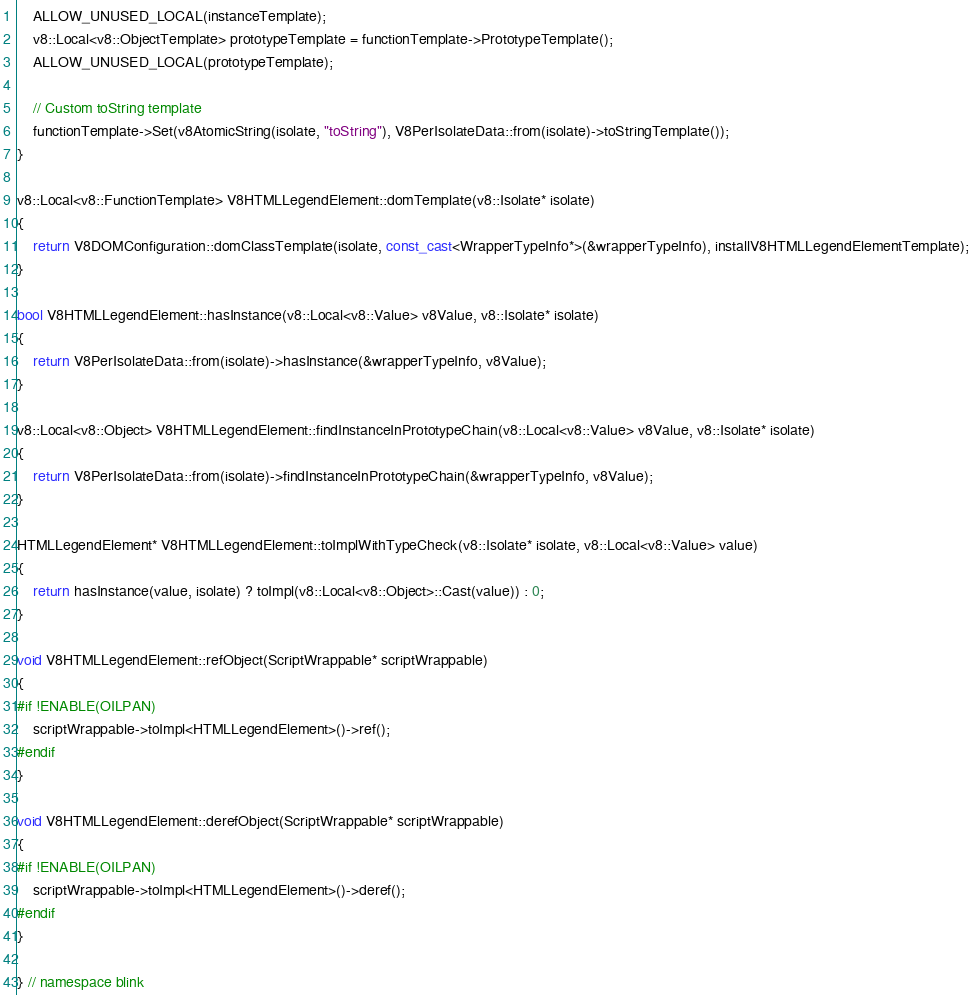Convert code to text. <code><loc_0><loc_0><loc_500><loc_500><_C++_>    ALLOW_UNUSED_LOCAL(instanceTemplate);
    v8::Local<v8::ObjectTemplate> prototypeTemplate = functionTemplate->PrototypeTemplate();
    ALLOW_UNUSED_LOCAL(prototypeTemplate);

    // Custom toString template
    functionTemplate->Set(v8AtomicString(isolate, "toString"), V8PerIsolateData::from(isolate)->toStringTemplate());
}

v8::Local<v8::FunctionTemplate> V8HTMLLegendElement::domTemplate(v8::Isolate* isolate)
{
    return V8DOMConfiguration::domClassTemplate(isolate, const_cast<WrapperTypeInfo*>(&wrapperTypeInfo), installV8HTMLLegendElementTemplate);
}

bool V8HTMLLegendElement::hasInstance(v8::Local<v8::Value> v8Value, v8::Isolate* isolate)
{
    return V8PerIsolateData::from(isolate)->hasInstance(&wrapperTypeInfo, v8Value);
}

v8::Local<v8::Object> V8HTMLLegendElement::findInstanceInPrototypeChain(v8::Local<v8::Value> v8Value, v8::Isolate* isolate)
{
    return V8PerIsolateData::from(isolate)->findInstanceInPrototypeChain(&wrapperTypeInfo, v8Value);
}

HTMLLegendElement* V8HTMLLegendElement::toImplWithTypeCheck(v8::Isolate* isolate, v8::Local<v8::Value> value)
{
    return hasInstance(value, isolate) ? toImpl(v8::Local<v8::Object>::Cast(value)) : 0;
}

void V8HTMLLegendElement::refObject(ScriptWrappable* scriptWrappable)
{
#if !ENABLE(OILPAN)
    scriptWrappable->toImpl<HTMLLegendElement>()->ref();
#endif
}

void V8HTMLLegendElement::derefObject(ScriptWrappable* scriptWrappable)
{
#if !ENABLE(OILPAN)
    scriptWrappable->toImpl<HTMLLegendElement>()->deref();
#endif
}

} // namespace blink
</code> 